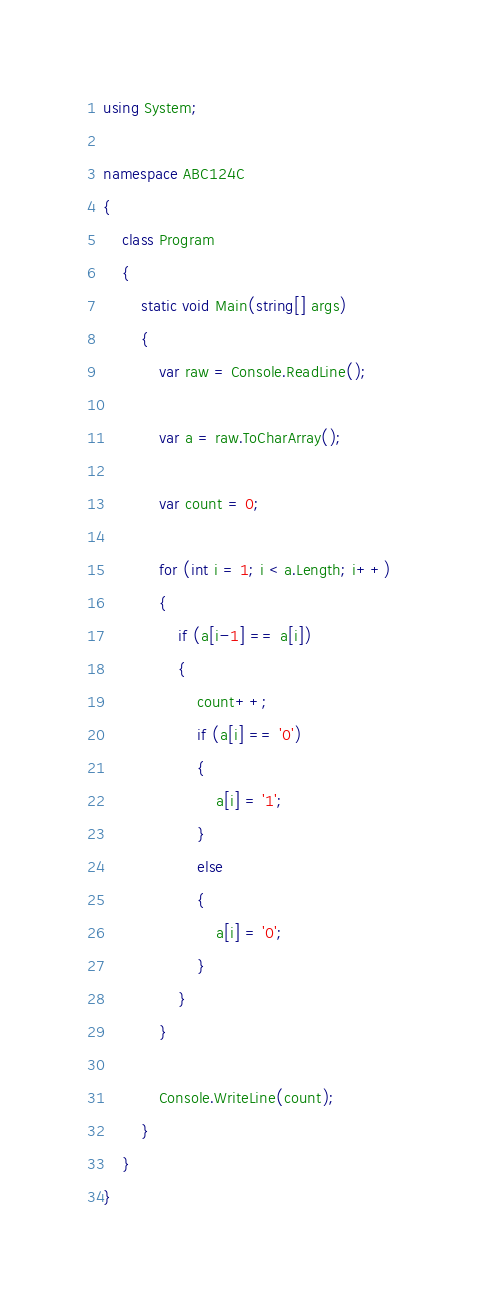<code> <loc_0><loc_0><loc_500><loc_500><_C#_>using System;

namespace ABC124C
{
    class Program
    {
        static void Main(string[] args)
        {
            var raw = Console.ReadLine();

            var a = raw.ToCharArray();

            var count = 0;

            for (int i = 1; i < a.Length; i++)
            {
                if (a[i-1] == a[i])
                {
                    count++;
                    if (a[i] == '0')
                    {
                        a[i] = '1';
                    }
                    else
                    {
                        a[i] = '0';
                    }
                }
            }

            Console.WriteLine(count);
        }
    }
}
</code> 